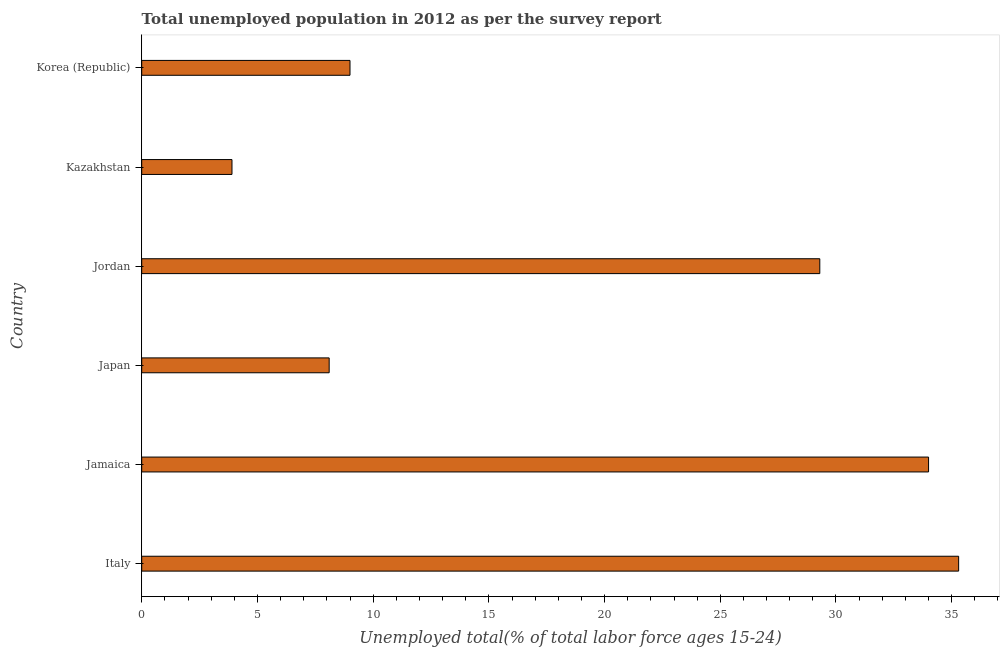Does the graph contain any zero values?
Make the answer very short. No. Does the graph contain grids?
Offer a terse response. No. What is the title of the graph?
Your answer should be compact. Total unemployed population in 2012 as per the survey report. What is the label or title of the X-axis?
Make the answer very short. Unemployed total(% of total labor force ages 15-24). What is the label or title of the Y-axis?
Offer a terse response. Country. What is the unemployed youth in Jordan?
Keep it short and to the point. 29.3. Across all countries, what is the maximum unemployed youth?
Your answer should be compact. 35.3. Across all countries, what is the minimum unemployed youth?
Make the answer very short. 3.9. In which country was the unemployed youth maximum?
Keep it short and to the point. Italy. In which country was the unemployed youth minimum?
Give a very brief answer. Kazakhstan. What is the sum of the unemployed youth?
Make the answer very short. 119.6. What is the difference between the unemployed youth in Jamaica and Japan?
Offer a very short reply. 25.9. What is the average unemployed youth per country?
Provide a short and direct response. 19.93. What is the median unemployed youth?
Make the answer very short. 19.15. In how many countries, is the unemployed youth greater than 24 %?
Your answer should be very brief. 3. What is the ratio of the unemployed youth in Jamaica to that in Kazakhstan?
Provide a succinct answer. 8.72. Is the sum of the unemployed youth in Italy and Korea (Republic) greater than the maximum unemployed youth across all countries?
Ensure brevity in your answer.  Yes. What is the difference between the highest and the lowest unemployed youth?
Give a very brief answer. 31.4. How many bars are there?
Your answer should be very brief. 6. What is the difference between two consecutive major ticks on the X-axis?
Offer a terse response. 5. Are the values on the major ticks of X-axis written in scientific E-notation?
Your response must be concise. No. What is the Unemployed total(% of total labor force ages 15-24) in Italy?
Make the answer very short. 35.3. What is the Unemployed total(% of total labor force ages 15-24) of Japan?
Make the answer very short. 8.1. What is the Unemployed total(% of total labor force ages 15-24) of Jordan?
Your answer should be compact. 29.3. What is the Unemployed total(% of total labor force ages 15-24) in Kazakhstan?
Give a very brief answer. 3.9. What is the Unemployed total(% of total labor force ages 15-24) in Korea (Republic)?
Provide a succinct answer. 9. What is the difference between the Unemployed total(% of total labor force ages 15-24) in Italy and Jamaica?
Offer a terse response. 1.3. What is the difference between the Unemployed total(% of total labor force ages 15-24) in Italy and Japan?
Your response must be concise. 27.2. What is the difference between the Unemployed total(% of total labor force ages 15-24) in Italy and Jordan?
Provide a short and direct response. 6. What is the difference between the Unemployed total(% of total labor force ages 15-24) in Italy and Kazakhstan?
Make the answer very short. 31.4. What is the difference between the Unemployed total(% of total labor force ages 15-24) in Italy and Korea (Republic)?
Your answer should be compact. 26.3. What is the difference between the Unemployed total(% of total labor force ages 15-24) in Jamaica and Japan?
Your response must be concise. 25.9. What is the difference between the Unemployed total(% of total labor force ages 15-24) in Jamaica and Jordan?
Your response must be concise. 4.7. What is the difference between the Unemployed total(% of total labor force ages 15-24) in Jamaica and Kazakhstan?
Your answer should be very brief. 30.1. What is the difference between the Unemployed total(% of total labor force ages 15-24) in Jamaica and Korea (Republic)?
Your answer should be very brief. 25. What is the difference between the Unemployed total(% of total labor force ages 15-24) in Japan and Jordan?
Give a very brief answer. -21.2. What is the difference between the Unemployed total(% of total labor force ages 15-24) in Japan and Kazakhstan?
Offer a very short reply. 4.2. What is the difference between the Unemployed total(% of total labor force ages 15-24) in Japan and Korea (Republic)?
Ensure brevity in your answer.  -0.9. What is the difference between the Unemployed total(% of total labor force ages 15-24) in Jordan and Kazakhstan?
Give a very brief answer. 25.4. What is the difference between the Unemployed total(% of total labor force ages 15-24) in Jordan and Korea (Republic)?
Make the answer very short. 20.3. What is the ratio of the Unemployed total(% of total labor force ages 15-24) in Italy to that in Jamaica?
Provide a succinct answer. 1.04. What is the ratio of the Unemployed total(% of total labor force ages 15-24) in Italy to that in Japan?
Your response must be concise. 4.36. What is the ratio of the Unemployed total(% of total labor force ages 15-24) in Italy to that in Jordan?
Offer a very short reply. 1.21. What is the ratio of the Unemployed total(% of total labor force ages 15-24) in Italy to that in Kazakhstan?
Provide a succinct answer. 9.05. What is the ratio of the Unemployed total(% of total labor force ages 15-24) in Italy to that in Korea (Republic)?
Offer a terse response. 3.92. What is the ratio of the Unemployed total(% of total labor force ages 15-24) in Jamaica to that in Japan?
Make the answer very short. 4.2. What is the ratio of the Unemployed total(% of total labor force ages 15-24) in Jamaica to that in Jordan?
Your answer should be compact. 1.16. What is the ratio of the Unemployed total(% of total labor force ages 15-24) in Jamaica to that in Kazakhstan?
Your answer should be very brief. 8.72. What is the ratio of the Unemployed total(% of total labor force ages 15-24) in Jamaica to that in Korea (Republic)?
Your response must be concise. 3.78. What is the ratio of the Unemployed total(% of total labor force ages 15-24) in Japan to that in Jordan?
Ensure brevity in your answer.  0.28. What is the ratio of the Unemployed total(% of total labor force ages 15-24) in Japan to that in Kazakhstan?
Your answer should be very brief. 2.08. What is the ratio of the Unemployed total(% of total labor force ages 15-24) in Jordan to that in Kazakhstan?
Keep it short and to the point. 7.51. What is the ratio of the Unemployed total(% of total labor force ages 15-24) in Jordan to that in Korea (Republic)?
Offer a very short reply. 3.26. What is the ratio of the Unemployed total(% of total labor force ages 15-24) in Kazakhstan to that in Korea (Republic)?
Provide a short and direct response. 0.43. 